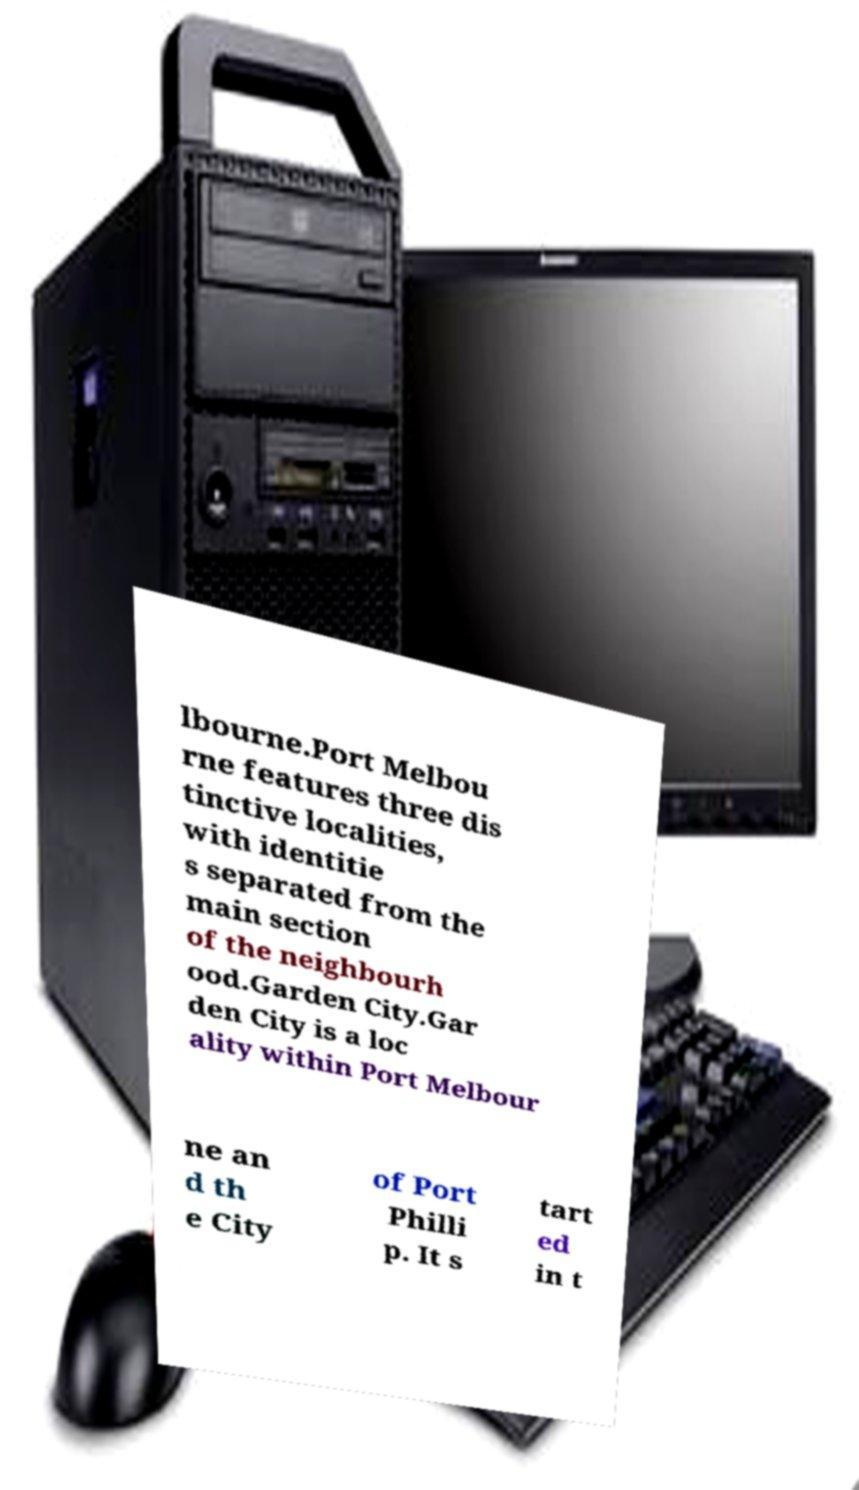Please read and relay the text visible in this image. What does it say? lbourne.Port Melbou rne features three dis tinctive localities, with identitie s separated from the main section of the neighbourh ood.Garden City.Gar den City is a loc ality within Port Melbour ne an d th e City of Port Philli p. It s tart ed in t 